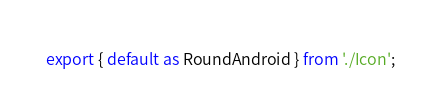Convert code to text. <code><loc_0><loc_0><loc_500><loc_500><_TypeScript_>export { default as RoundAndroid } from './Icon';
</code> 